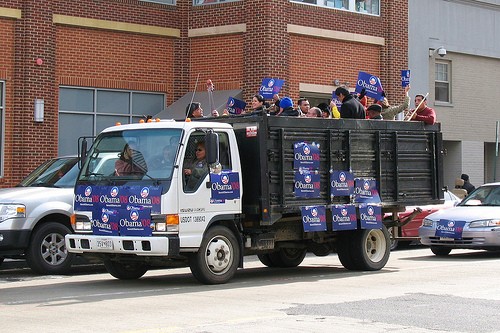Please provide the bounding box coordinate of the region this sentence describes: Collection of Obama signs on side of truck. The bounding box coordinates describing the collection of Obama signs on the side of the truck are: [0.58, 0.45, 0.79, 0.65]. 